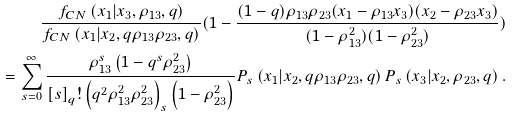<formula> <loc_0><loc_0><loc_500><loc_500>\frac { f _ { C N } \left ( x _ { 1 } | x _ { 3 } , \rho _ { 1 3 } , q \right ) } { f _ { C N } \left ( x _ { 1 } | x _ { 2 } , q \rho _ { 1 3 } \rho _ { 2 3 } , q \right ) } ( 1 - \frac { ( 1 - q ) \rho _ { 1 3 } \rho _ { 2 3 } ( x _ { 1 } - \rho _ { 1 3 } x _ { 3 } ) ( x _ { 2 } - \rho _ { 2 3 } x _ { 3 } ) } { ( 1 - \rho _ { 1 3 } ^ { 2 } ) ( 1 - \rho _ { 2 3 } ^ { 2 } ) } ) \\ = \sum _ { s = 0 } ^ { \infty } \frac { \rho _ { 1 3 } ^ { s } \left ( 1 - q ^ { s } \rho _ { 2 3 } ^ { 2 } \right ) } { \left [ s \right ] _ { q } ! \left ( q ^ { 2 } \rho _ { 1 3 } ^ { 2 } \rho _ { 2 3 } ^ { 2 } \right ) _ { s } \left ( 1 - \rho _ { 2 3 } ^ { 2 } \right ) } P _ { s } \left ( x _ { 1 } | x _ { 2 } , q \rho _ { 1 3 } \rho _ { 2 3 } , q \right ) P _ { s } \left ( x _ { 3 } | x _ { 2 } , \rho _ { 2 3 } , q \right ) .</formula> 